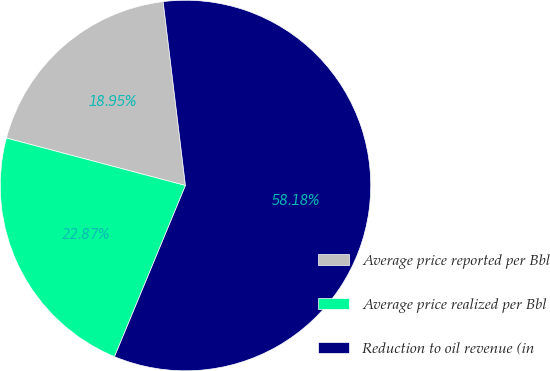Convert chart. <chart><loc_0><loc_0><loc_500><loc_500><pie_chart><fcel>Average price reported per Bbl<fcel>Average price realized per Bbl<fcel>Reduction to oil revenue (in<nl><fcel>18.95%<fcel>22.87%<fcel>58.17%<nl></chart> 